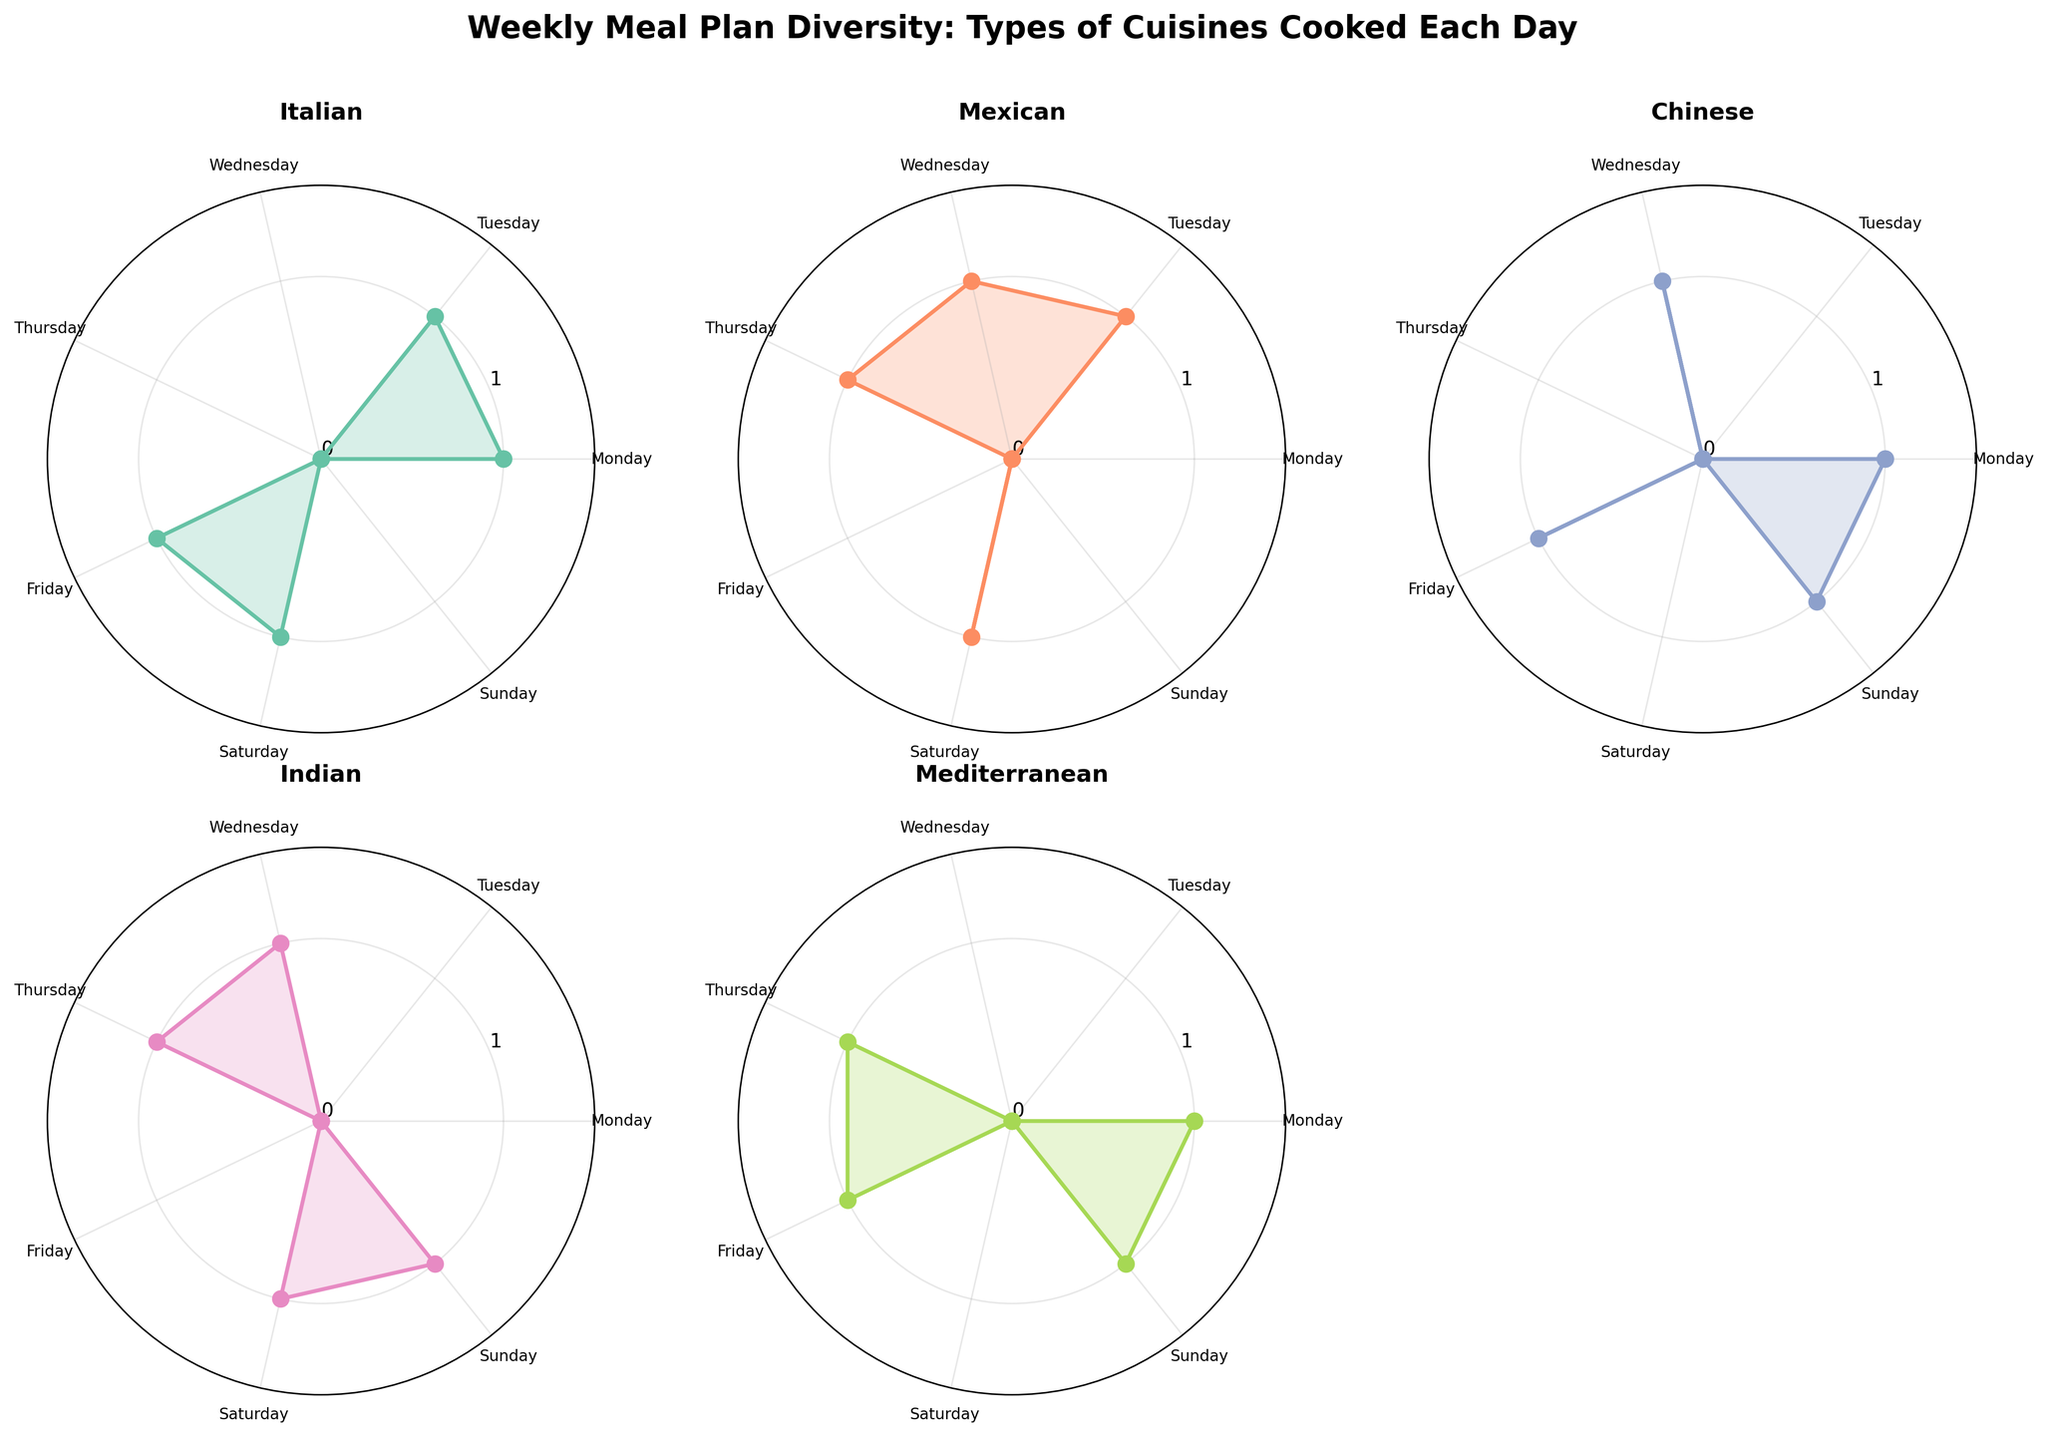What type of cuisine is depicted in the first subplot? The first subplot shows the cuisine type at the top of the subplot. Reading from left to right, the first cuisine type shown is 'Italian'.
Answer: Italian How many times was Italian cuisine cooked throughout the week? By adding the counts given in the Italian subplot: Monday (1), Tuesday (1), Friday (1), Saturday (1). Sum is 1+1+1+1=4.
Answer: 4 Which day has the most diverse cuisine types cooked? Counting the number of cuisines in each day's subplots, Tuesday and Saturday both have 4 cuisines cooked: Italian, Mexican, Chinese, and Mediterranean on Tuesday, and Italian, Mexican, Indian, and Chinese on Saturday.
Answer: Tuesday and Saturday Which type of cuisine has the least number of meals for the entire week? Summing up all the counts for each cuisine in their respective plots, Mediterranean cuisine is cooked 4 times, which is less than the other cuisines.
Answer: Mediterranean How are the axes labeled for each subplot? Each subplot has the days of the week as the labels around the polar plot: Monday, Tuesday, Wednesday, Thursday, Friday, Saturday, Sunday.
Answer: Days of the week On which day is Chinese cuisine cooked the most? By examining the Chinese subplot, Chinese cuisine is cooked on Monday, Wednesday, Friday, and Sunday. Each count is 1, but it is equal on all these days.
Answer: Monday, Wednesday, Friday, and Sunday How many cuisines are plotted in total? By looking at the number of subplots and titles, there are 5 cuisines: Italian, Mexican, Chinese, Indian, Mediterranean.
Answer: 5 What is the unique feature of the Mediterranean subplot on Friday compared to the other days? The Mediterranean subplot on Friday has a count of 1, whereas the other days have varied counts, making Friday a notable peak in the plot.
Answer: Peak on Friday 